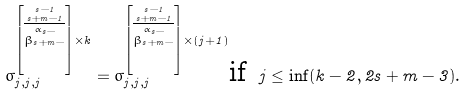<formula> <loc_0><loc_0><loc_500><loc_500>\sigma _ { j , j , j } ^ { \left [ \stackrel { s - 1 } { \stackrel { s + m - 1 } { \overline { \stackrel { \alpha _ { s - } } { \beta _ { s + m - } } } } } \right ] \times k } = \sigma _ { j , j , j } ^ { \left [ \stackrel { s - 1 } { \stackrel { s + m - 1 } { \overline { \stackrel { \alpha _ { s - } } { \beta _ { s + m - } } } } } \right ] \times ( j + 1 ) } \text {if } \, j \leq \inf ( k - 2 , 2 s + m - 3 ) .</formula> 